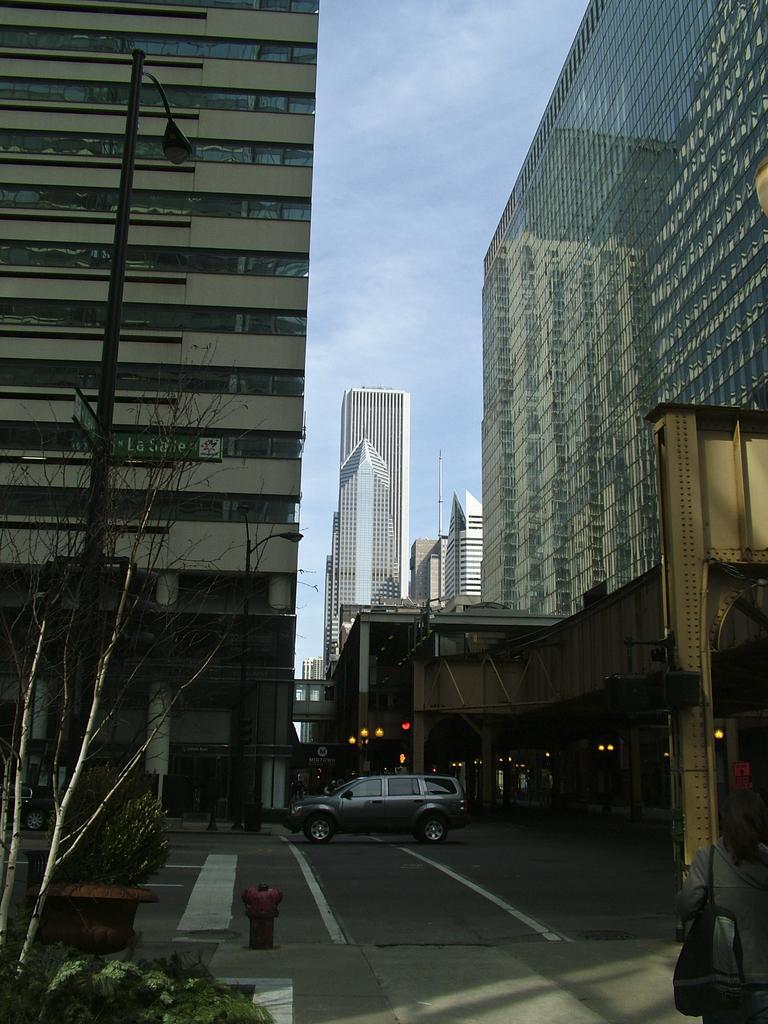Describe this image in one or two sentences. This image is taken outdoors. At the top of the image there is a sky with clouds. At the bottom of the image there is a road. In the middle of the image there are a few buildings. There are a few street lights and a car is parked on the road. On the left side of the image there is a tree and there are two plants in the pots and there is a hydrant. On the right side of the image there is a man. 